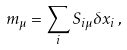Convert formula to latex. <formula><loc_0><loc_0><loc_500><loc_500>m _ { \mu } = \sum _ { i } S _ { i \mu } \delta x _ { i } \, ,</formula> 